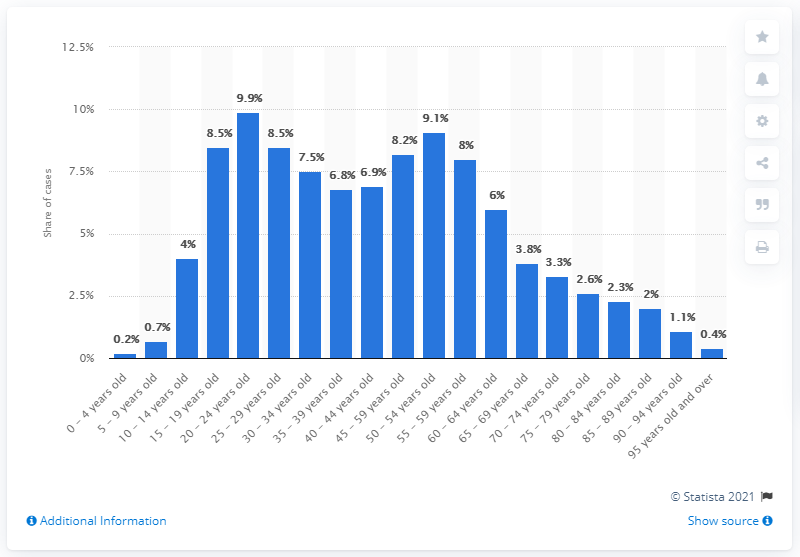Mention a couple of crucial points in this snapshot. Approximately 10% of COVID-19 cases occurred in individuals aged 20-24. 